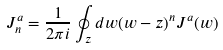Convert formula to latex. <formula><loc_0><loc_0><loc_500><loc_500>J _ { n } ^ { a } = \frac { 1 } { 2 \pi i } \oint _ { z } d w ( w - z ) ^ { n } J ^ { a } ( w )</formula> 